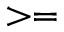Convert formula to latex. <formula><loc_0><loc_0><loc_500><loc_500>> =</formula> 